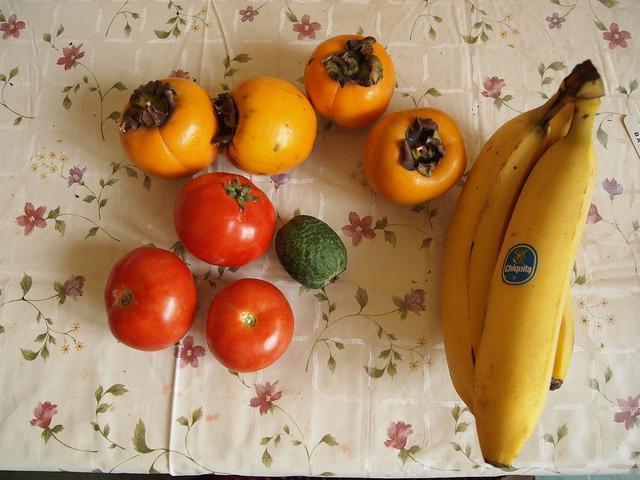How many tomatoes?
Give a very brief answer. 7. How many train cars are in the picture?
Give a very brief answer. 0. 